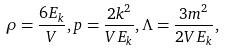Convert formula to latex. <formula><loc_0><loc_0><loc_500><loc_500>\rho = \frac { 6 E _ { k } } { V } , p = \frac { 2 k ^ { 2 } } { V E _ { k } } , \Lambda = \frac { 3 m ^ { 2 } } { 2 V E _ { k } } ,</formula> 